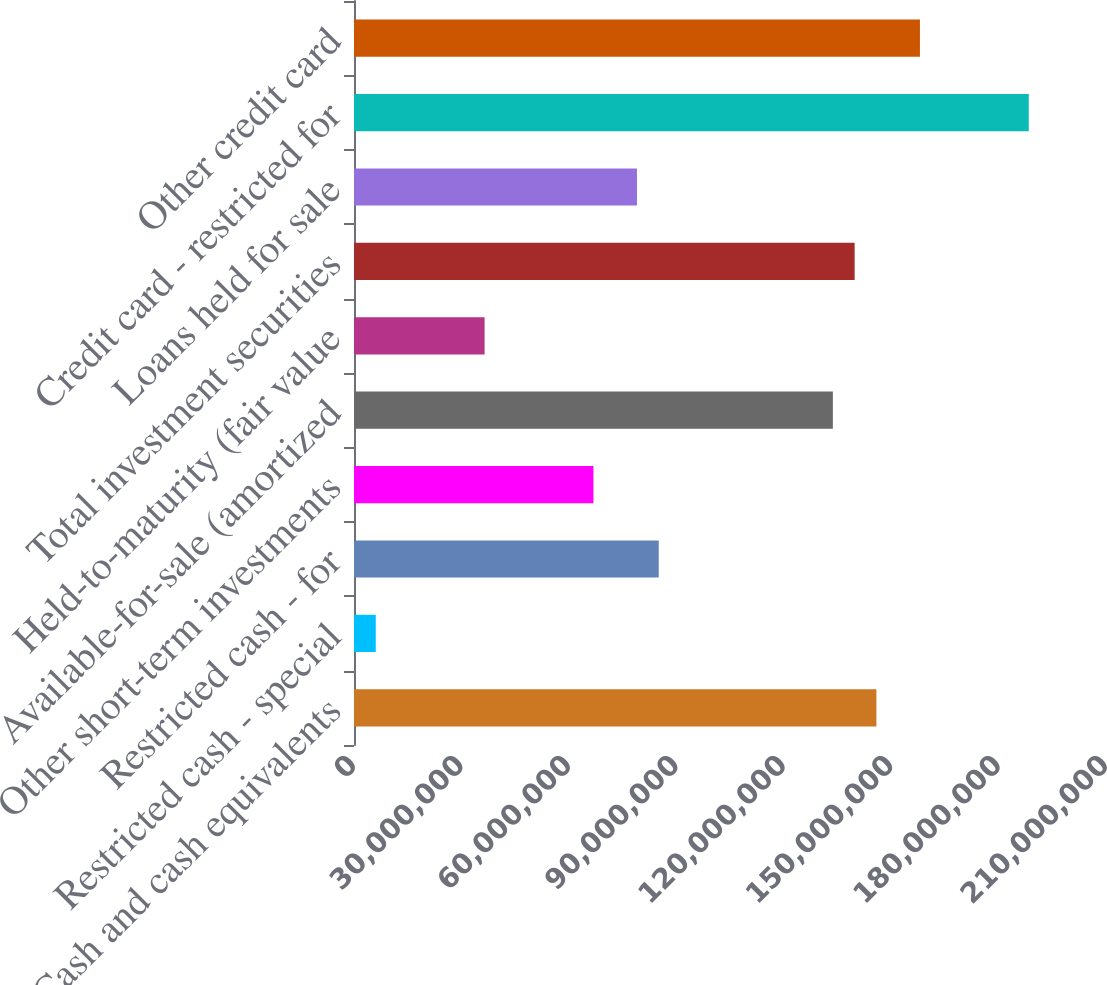Convert chart. <chart><loc_0><loc_0><loc_500><loc_500><bar_chart><fcel>Cash and cash equivalents<fcel>Restricted cash - special<fcel>Restricted cash - for<fcel>Other short-term investments<fcel>Available-for-sale (amortized<fcel>Held-to-maturity (fair value<fcel>Total investment securities<fcel>Loans held for sale<fcel>Credit card - restricted for<fcel>Other credit card<nl><fcel>1.45884e+08<fcel>6.0785e+06<fcel>8.5099e+07<fcel>6.68635e+07<fcel>1.33727e+08<fcel>3.6471e+07<fcel>1.39805e+08<fcel>7.90205e+07<fcel>1.88433e+08<fcel>1.58041e+08<nl></chart> 